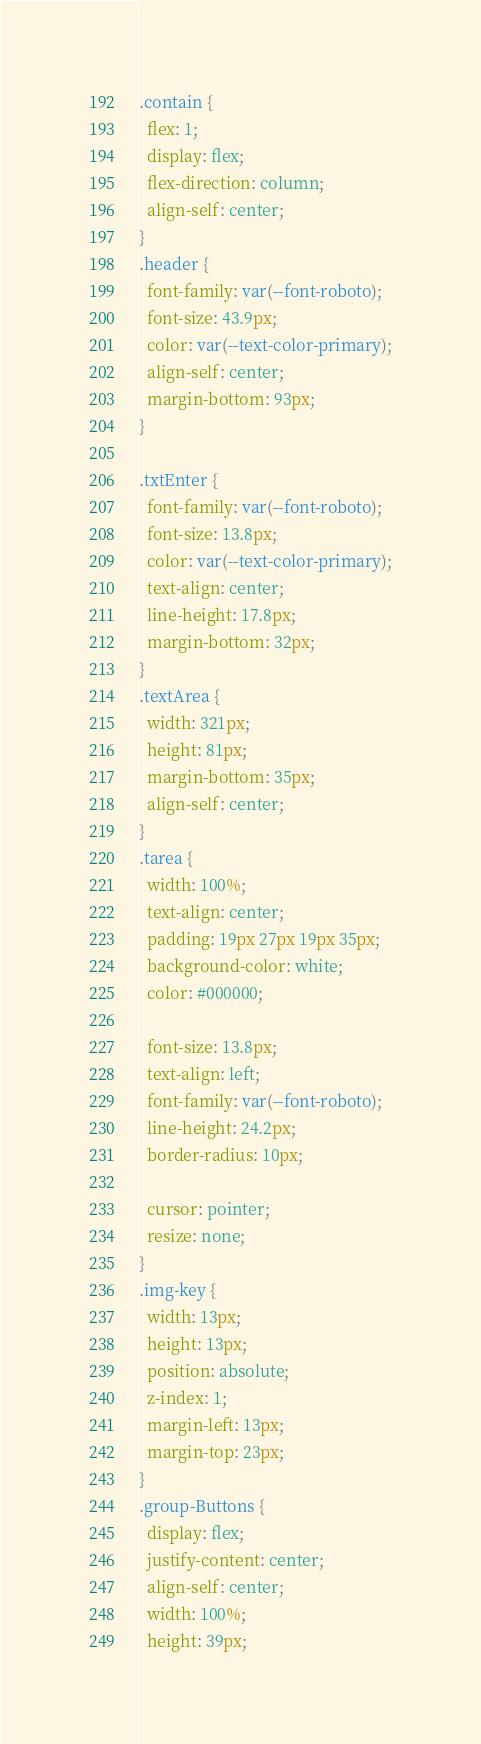<code> <loc_0><loc_0><loc_500><loc_500><_CSS_>.contain {
  flex: 1;
  display: flex;
  flex-direction: column;
  align-self: center;
}
.header {
  font-family: var(--font-roboto);
  font-size: 43.9px;
  color: var(--text-color-primary);
  align-self: center;
  margin-bottom: 93px;
}

.txtEnter {
  font-family: var(--font-roboto);
  font-size: 13.8px;
  color: var(--text-color-primary);
  text-align: center;
  line-height: 17.8px;
  margin-bottom: 32px;
}
.textArea {
  width: 321px;
  height: 81px;
  margin-bottom: 35px;
  align-self: center;
}
.tarea {
  width: 100%;
  text-align: center;
  padding: 19px 27px 19px 35px;
  background-color: white;
  color: #000000;
  
  font-size: 13.8px;
  text-align: left;
  font-family: var(--font-roboto);
  line-height: 24.2px;
  border-radius: 10px;
  
  cursor: pointer;
  resize: none;
}
.img-key {
  width: 13px;
  height: 13px;
  position: absolute;
  z-index: 1;
  margin-left: 13px;
  margin-top: 23px;
}
.group-Buttons {
  display: flex;
  justify-content: center;
  align-self: center;
  width: 100%;
  height: 39px;</code> 